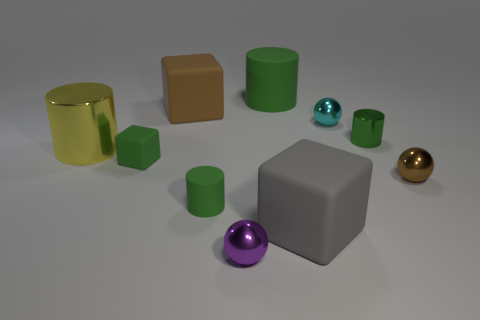Is the tiny metallic cylinder the same color as the large rubber cylinder?
Offer a very short reply. Yes. There is a big cube to the right of the tiny cylinder that is left of the green metal thing; how many yellow shiny things are behind it?
Offer a very short reply. 1. Are there any other things that are the same color as the large matte cylinder?
Offer a very short reply. Yes. There is a brown thing left of the purple metallic object; is it the same size as the brown ball?
Your answer should be very brief. No. There is a green rubber cylinder that is in front of the large shiny object; what number of tiny shiny balls are behind it?
Offer a terse response. 2. Is there a small green object that is to the right of the small green cylinder in front of the metal cylinder on the left side of the big brown thing?
Provide a succinct answer. Yes. There is a big yellow thing that is the same shape as the small green metallic thing; what is its material?
Your answer should be very brief. Metal. Are there any other things that have the same material as the large gray block?
Offer a terse response. Yes. Is the material of the yellow cylinder the same as the block that is right of the small purple shiny sphere?
Offer a very short reply. No. What shape is the large yellow metal thing that is behind the gray cube to the right of the yellow object?
Provide a short and direct response. Cylinder. 